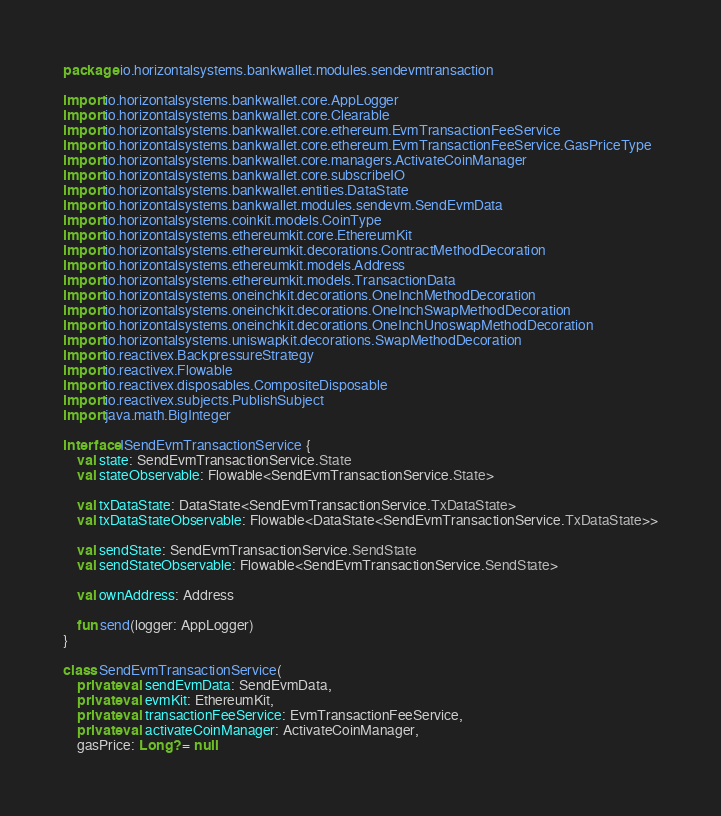<code> <loc_0><loc_0><loc_500><loc_500><_Kotlin_>package io.horizontalsystems.bankwallet.modules.sendevmtransaction

import io.horizontalsystems.bankwallet.core.AppLogger
import io.horizontalsystems.bankwallet.core.Clearable
import io.horizontalsystems.bankwallet.core.ethereum.EvmTransactionFeeService
import io.horizontalsystems.bankwallet.core.ethereum.EvmTransactionFeeService.GasPriceType
import io.horizontalsystems.bankwallet.core.managers.ActivateCoinManager
import io.horizontalsystems.bankwallet.core.subscribeIO
import io.horizontalsystems.bankwallet.entities.DataState
import io.horizontalsystems.bankwallet.modules.sendevm.SendEvmData
import io.horizontalsystems.coinkit.models.CoinType
import io.horizontalsystems.ethereumkit.core.EthereumKit
import io.horizontalsystems.ethereumkit.decorations.ContractMethodDecoration
import io.horizontalsystems.ethereumkit.models.Address
import io.horizontalsystems.ethereumkit.models.TransactionData
import io.horizontalsystems.oneinchkit.decorations.OneInchMethodDecoration
import io.horizontalsystems.oneinchkit.decorations.OneInchSwapMethodDecoration
import io.horizontalsystems.oneinchkit.decorations.OneInchUnoswapMethodDecoration
import io.horizontalsystems.uniswapkit.decorations.SwapMethodDecoration
import io.reactivex.BackpressureStrategy
import io.reactivex.Flowable
import io.reactivex.disposables.CompositeDisposable
import io.reactivex.subjects.PublishSubject
import java.math.BigInteger

interface ISendEvmTransactionService {
    val state: SendEvmTransactionService.State
    val stateObservable: Flowable<SendEvmTransactionService.State>

    val txDataState: DataState<SendEvmTransactionService.TxDataState>
    val txDataStateObservable: Flowable<DataState<SendEvmTransactionService.TxDataState>>

    val sendState: SendEvmTransactionService.SendState
    val sendStateObservable: Flowable<SendEvmTransactionService.SendState>

    val ownAddress: Address

    fun send(logger: AppLogger)
}

class SendEvmTransactionService(
    private val sendEvmData: SendEvmData,
    private val evmKit: EthereumKit,
    private val transactionFeeService: EvmTransactionFeeService,
    private val activateCoinManager: ActivateCoinManager,
    gasPrice: Long? = null</code> 